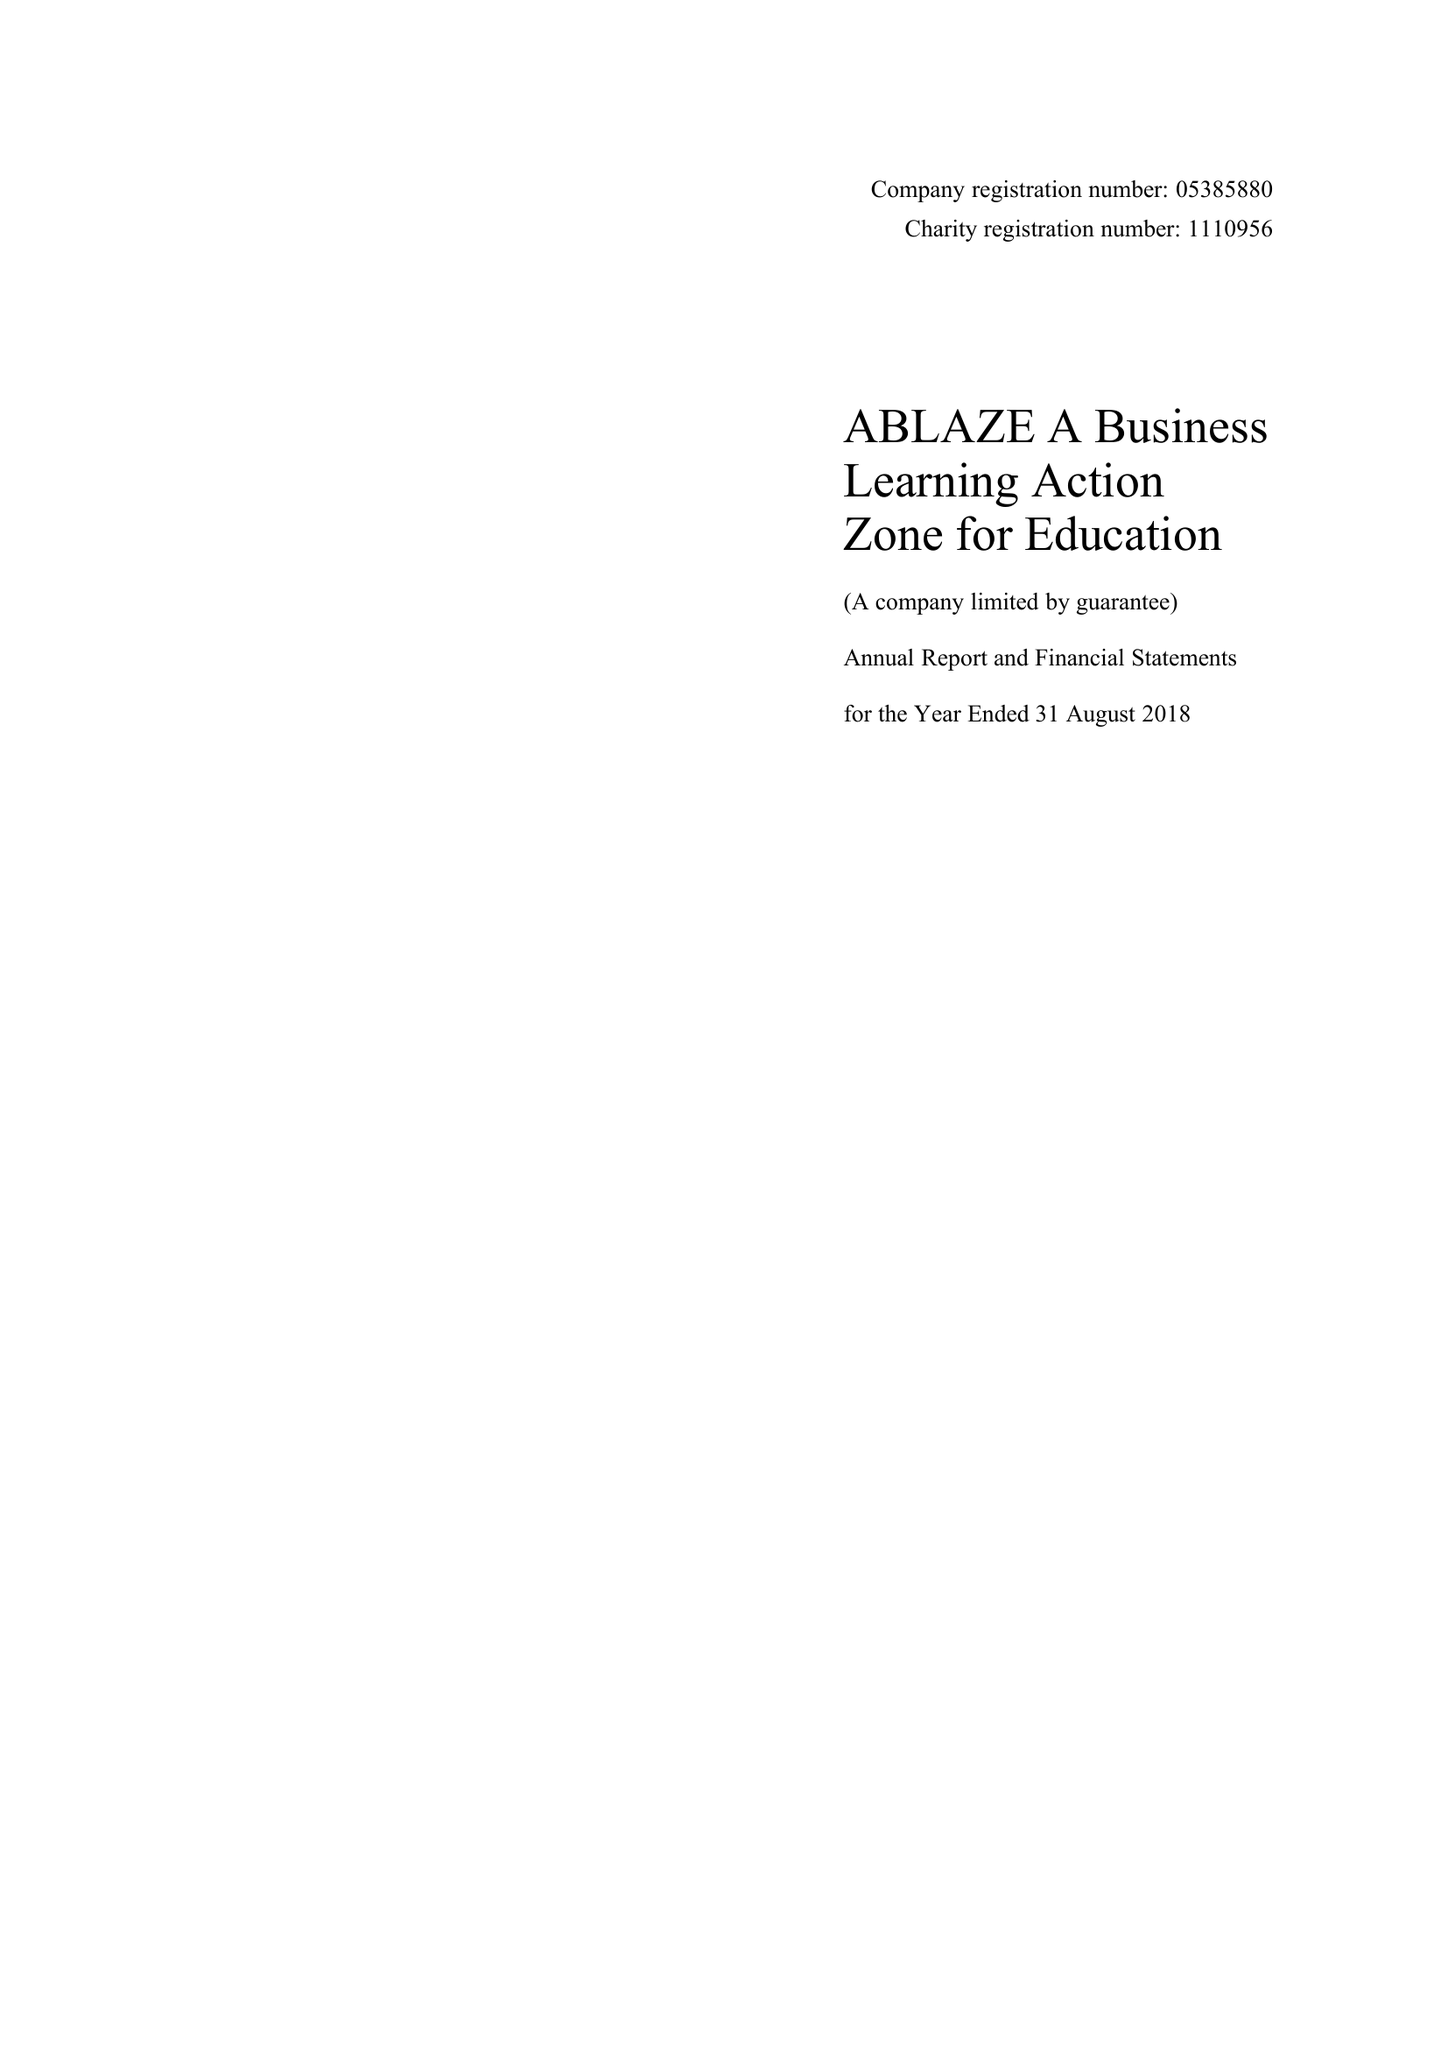What is the value for the address__postcode?
Answer the question using a single word or phrase. BS1 6NL 